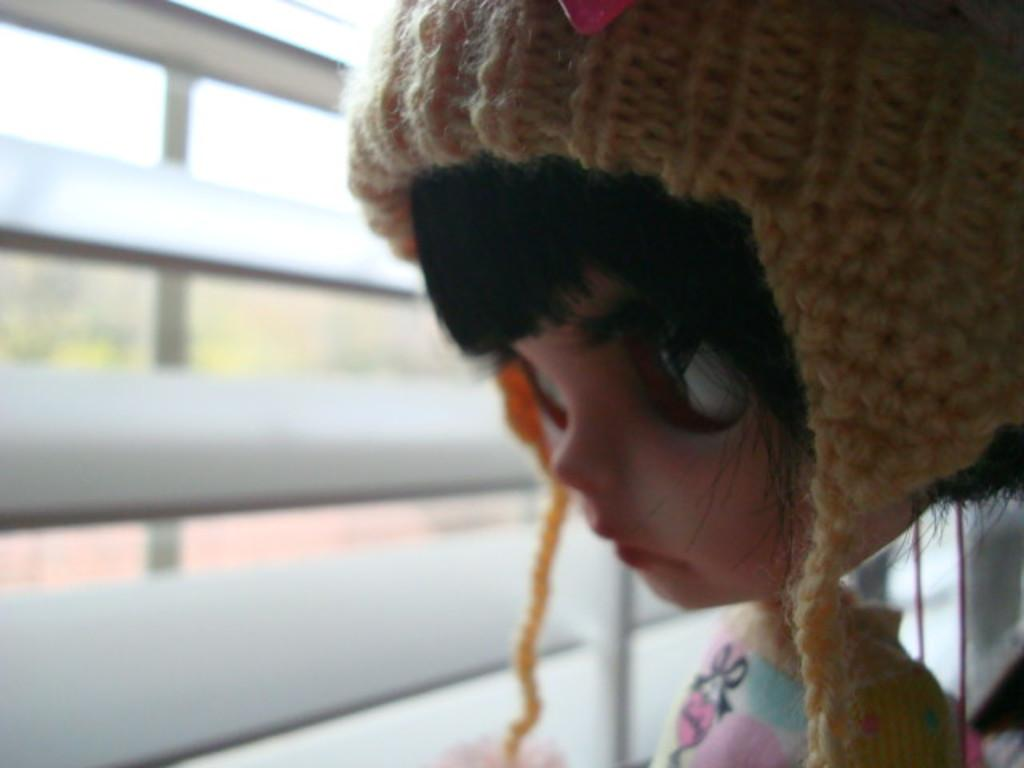What is present in the image? There is a doll in the image. What else can be seen in the image? There is a window in the image. What type of bubble is the doll holding in the image? There is no bubble present in the image; it only features a doll and a window. What color is the dress the doll is wearing in the image? The provided facts do not mention the doll wearing a dress, nor do they mention the color of any clothing. 